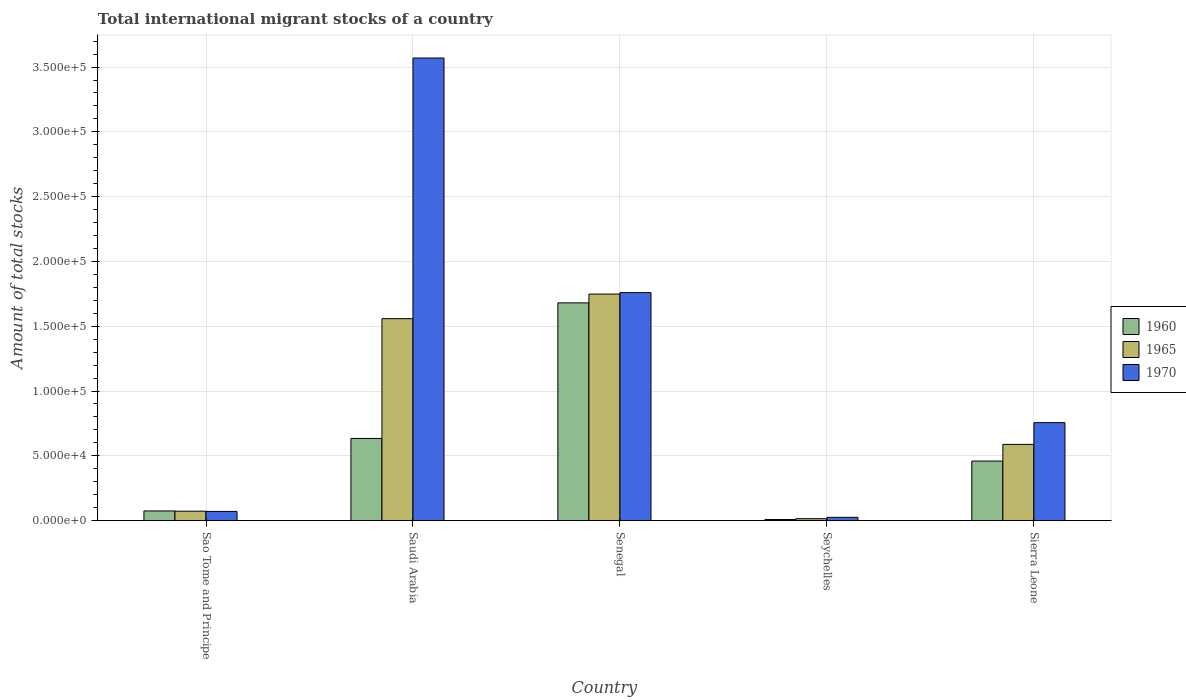Are the number of bars on each tick of the X-axis equal?
Offer a terse response. Yes. How many bars are there on the 5th tick from the left?
Provide a succinct answer. 3. What is the label of the 1st group of bars from the left?
Ensure brevity in your answer.  Sao Tome and Principe. What is the amount of total stocks in in 1970 in Saudi Arabia?
Make the answer very short. 3.57e+05. Across all countries, what is the maximum amount of total stocks in in 1965?
Give a very brief answer. 1.75e+05. Across all countries, what is the minimum amount of total stocks in in 1965?
Keep it short and to the point. 1455. In which country was the amount of total stocks in in 1965 maximum?
Offer a very short reply. Senegal. In which country was the amount of total stocks in in 1960 minimum?
Ensure brevity in your answer.  Seychelles. What is the total amount of total stocks in in 1965 in the graph?
Provide a short and direct response. 3.98e+05. What is the difference between the amount of total stocks in in 1965 in Saudi Arabia and that in Sierra Leone?
Your answer should be compact. 9.70e+04. What is the difference between the amount of total stocks in in 1965 in Sao Tome and Principe and the amount of total stocks in in 1960 in Sierra Leone?
Give a very brief answer. -3.87e+04. What is the average amount of total stocks in in 1960 per country?
Your answer should be compact. 5.71e+04. What is the difference between the amount of total stocks in of/in 1965 and amount of total stocks in of/in 1960 in Sierra Leone?
Provide a short and direct response. 1.29e+04. In how many countries, is the amount of total stocks in in 1960 greater than 190000?
Ensure brevity in your answer.  0. What is the ratio of the amount of total stocks in in 1965 in Sao Tome and Principe to that in Saudi Arabia?
Offer a very short reply. 0.05. Is the difference between the amount of total stocks in in 1965 in Saudi Arabia and Seychelles greater than the difference between the amount of total stocks in in 1960 in Saudi Arabia and Seychelles?
Provide a short and direct response. Yes. What is the difference between the highest and the second highest amount of total stocks in in 1970?
Make the answer very short. 1.81e+05. What is the difference between the highest and the lowest amount of total stocks in in 1960?
Offer a terse response. 1.67e+05. Is the sum of the amount of total stocks in in 1970 in Sao Tome and Principe and Sierra Leone greater than the maximum amount of total stocks in in 1965 across all countries?
Provide a short and direct response. No. Is it the case that in every country, the sum of the amount of total stocks in in 1960 and amount of total stocks in in 1965 is greater than the amount of total stocks in in 1970?
Your answer should be very brief. No. Are all the bars in the graph horizontal?
Offer a very short reply. No. What is the difference between two consecutive major ticks on the Y-axis?
Give a very brief answer. 5.00e+04. Are the values on the major ticks of Y-axis written in scientific E-notation?
Your answer should be very brief. Yes. Does the graph contain grids?
Make the answer very short. Yes. How many legend labels are there?
Offer a terse response. 3. What is the title of the graph?
Make the answer very short. Total international migrant stocks of a country. What is the label or title of the Y-axis?
Provide a short and direct response. Amount of total stocks. What is the Amount of total stocks in 1960 in Sao Tome and Principe?
Your answer should be very brief. 7436. What is the Amount of total stocks of 1965 in Sao Tome and Principe?
Your answer should be very brief. 7253. What is the Amount of total stocks of 1970 in Sao Tome and Principe?
Your answer should be very brief. 7074. What is the Amount of total stocks of 1960 in Saudi Arabia?
Ensure brevity in your answer.  6.34e+04. What is the Amount of total stocks in 1965 in Saudi Arabia?
Make the answer very short. 1.56e+05. What is the Amount of total stocks in 1970 in Saudi Arabia?
Your response must be concise. 3.57e+05. What is the Amount of total stocks in 1960 in Senegal?
Offer a very short reply. 1.68e+05. What is the Amount of total stocks in 1965 in Senegal?
Your response must be concise. 1.75e+05. What is the Amount of total stocks of 1970 in Senegal?
Offer a very short reply. 1.76e+05. What is the Amount of total stocks in 1960 in Seychelles?
Offer a terse response. 845. What is the Amount of total stocks of 1965 in Seychelles?
Offer a terse response. 1455. What is the Amount of total stocks of 1970 in Seychelles?
Keep it short and to the point. 2506. What is the Amount of total stocks in 1960 in Sierra Leone?
Ensure brevity in your answer.  4.59e+04. What is the Amount of total stocks in 1965 in Sierra Leone?
Provide a succinct answer. 5.88e+04. What is the Amount of total stocks of 1970 in Sierra Leone?
Your answer should be very brief. 7.56e+04. Across all countries, what is the maximum Amount of total stocks in 1960?
Offer a terse response. 1.68e+05. Across all countries, what is the maximum Amount of total stocks of 1965?
Provide a short and direct response. 1.75e+05. Across all countries, what is the maximum Amount of total stocks of 1970?
Your answer should be very brief. 3.57e+05. Across all countries, what is the minimum Amount of total stocks in 1960?
Provide a succinct answer. 845. Across all countries, what is the minimum Amount of total stocks in 1965?
Keep it short and to the point. 1455. Across all countries, what is the minimum Amount of total stocks in 1970?
Ensure brevity in your answer.  2506. What is the total Amount of total stocks in 1960 in the graph?
Your response must be concise. 2.86e+05. What is the total Amount of total stocks of 1965 in the graph?
Offer a terse response. 3.98e+05. What is the total Amount of total stocks of 1970 in the graph?
Your answer should be very brief. 6.18e+05. What is the difference between the Amount of total stocks in 1960 in Sao Tome and Principe and that in Saudi Arabia?
Provide a succinct answer. -5.60e+04. What is the difference between the Amount of total stocks in 1965 in Sao Tome and Principe and that in Saudi Arabia?
Your response must be concise. -1.49e+05. What is the difference between the Amount of total stocks in 1970 in Sao Tome and Principe and that in Saudi Arabia?
Offer a very short reply. -3.50e+05. What is the difference between the Amount of total stocks of 1960 in Sao Tome and Principe and that in Senegal?
Provide a succinct answer. -1.61e+05. What is the difference between the Amount of total stocks of 1965 in Sao Tome and Principe and that in Senegal?
Your answer should be compact. -1.68e+05. What is the difference between the Amount of total stocks of 1970 in Sao Tome and Principe and that in Senegal?
Your answer should be very brief. -1.69e+05. What is the difference between the Amount of total stocks of 1960 in Sao Tome and Principe and that in Seychelles?
Give a very brief answer. 6591. What is the difference between the Amount of total stocks of 1965 in Sao Tome and Principe and that in Seychelles?
Provide a short and direct response. 5798. What is the difference between the Amount of total stocks of 1970 in Sao Tome and Principe and that in Seychelles?
Your response must be concise. 4568. What is the difference between the Amount of total stocks in 1960 in Sao Tome and Principe and that in Sierra Leone?
Provide a short and direct response. -3.85e+04. What is the difference between the Amount of total stocks in 1965 in Sao Tome and Principe and that in Sierra Leone?
Keep it short and to the point. -5.16e+04. What is the difference between the Amount of total stocks of 1970 in Sao Tome and Principe and that in Sierra Leone?
Provide a short and direct response. -6.85e+04. What is the difference between the Amount of total stocks in 1960 in Saudi Arabia and that in Senegal?
Offer a very short reply. -1.05e+05. What is the difference between the Amount of total stocks in 1965 in Saudi Arabia and that in Senegal?
Give a very brief answer. -1.90e+04. What is the difference between the Amount of total stocks of 1970 in Saudi Arabia and that in Senegal?
Ensure brevity in your answer.  1.81e+05. What is the difference between the Amount of total stocks of 1960 in Saudi Arabia and that in Seychelles?
Offer a terse response. 6.25e+04. What is the difference between the Amount of total stocks in 1965 in Saudi Arabia and that in Seychelles?
Your response must be concise. 1.54e+05. What is the difference between the Amount of total stocks in 1970 in Saudi Arabia and that in Seychelles?
Your response must be concise. 3.54e+05. What is the difference between the Amount of total stocks of 1960 in Saudi Arabia and that in Sierra Leone?
Provide a short and direct response. 1.75e+04. What is the difference between the Amount of total stocks of 1965 in Saudi Arabia and that in Sierra Leone?
Your answer should be compact. 9.70e+04. What is the difference between the Amount of total stocks of 1970 in Saudi Arabia and that in Sierra Leone?
Keep it short and to the point. 2.81e+05. What is the difference between the Amount of total stocks in 1960 in Senegal and that in Seychelles?
Give a very brief answer. 1.67e+05. What is the difference between the Amount of total stocks of 1965 in Senegal and that in Seychelles?
Your answer should be very brief. 1.73e+05. What is the difference between the Amount of total stocks of 1970 in Senegal and that in Seychelles?
Offer a terse response. 1.73e+05. What is the difference between the Amount of total stocks of 1960 in Senegal and that in Sierra Leone?
Keep it short and to the point. 1.22e+05. What is the difference between the Amount of total stocks of 1965 in Senegal and that in Sierra Leone?
Your answer should be very brief. 1.16e+05. What is the difference between the Amount of total stocks in 1970 in Senegal and that in Sierra Leone?
Offer a terse response. 1.00e+05. What is the difference between the Amount of total stocks in 1960 in Seychelles and that in Sierra Leone?
Offer a terse response. -4.51e+04. What is the difference between the Amount of total stocks in 1965 in Seychelles and that in Sierra Leone?
Your answer should be very brief. -5.74e+04. What is the difference between the Amount of total stocks in 1970 in Seychelles and that in Sierra Leone?
Offer a terse response. -7.31e+04. What is the difference between the Amount of total stocks in 1960 in Sao Tome and Principe and the Amount of total stocks in 1965 in Saudi Arabia?
Your answer should be compact. -1.48e+05. What is the difference between the Amount of total stocks of 1960 in Sao Tome and Principe and the Amount of total stocks of 1970 in Saudi Arabia?
Ensure brevity in your answer.  -3.50e+05. What is the difference between the Amount of total stocks of 1965 in Sao Tome and Principe and the Amount of total stocks of 1970 in Saudi Arabia?
Offer a terse response. -3.50e+05. What is the difference between the Amount of total stocks of 1960 in Sao Tome and Principe and the Amount of total stocks of 1965 in Senegal?
Make the answer very short. -1.67e+05. What is the difference between the Amount of total stocks in 1960 in Sao Tome and Principe and the Amount of total stocks in 1970 in Senegal?
Make the answer very short. -1.68e+05. What is the difference between the Amount of total stocks of 1965 in Sao Tome and Principe and the Amount of total stocks of 1970 in Senegal?
Your answer should be very brief. -1.69e+05. What is the difference between the Amount of total stocks of 1960 in Sao Tome and Principe and the Amount of total stocks of 1965 in Seychelles?
Give a very brief answer. 5981. What is the difference between the Amount of total stocks of 1960 in Sao Tome and Principe and the Amount of total stocks of 1970 in Seychelles?
Your answer should be very brief. 4930. What is the difference between the Amount of total stocks in 1965 in Sao Tome and Principe and the Amount of total stocks in 1970 in Seychelles?
Give a very brief answer. 4747. What is the difference between the Amount of total stocks of 1960 in Sao Tome and Principe and the Amount of total stocks of 1965 in Sierra Leone?
Your answer should be compact. -5.14e+04. What is the difference between the Amount of total stocks of 1960 in Sao Tome and Principe and the Amount of total stocks of 1970 in Sierra Leone?
Your answer should be compact. -6.81e+04. What is the difference between the Amount of total stocks of 1965 in Sao Tome and Principe and the Amount of total stocks of 1970 in Sierra Leone?
Ensure brevity in your answer.  -6.83e+04. What is the difference between the Amount of total stocks of 1960 in Saudi Arabia and the Amount of total stocks of 1965 in Senegal?
Your answer should be compact. -1.11e+05. What is the difference between the Amount of total stocks in 1960 in Saudi Arabia and the Amount of total stocks in 1970 in Senegal?
Provide a succinct answer. -1.13e+05. What is the difference between the Amount of total stocks in 1965 in Saudi Arabia and the Amount of total stocks in 1970 in Senegal?
Make the answer very short. -2.01e+04. What is the difference between the Amount of total stocks of 1960 in Saudi Arabia and the Amount of total stocks of 1965 in Seychelles?
Ensure brevity in your answer.  6.19e+04. What is the difference between the Amount of total stocks of 1960 in Saudi Arabia and the Amount of total stocks of 1970 in Seychelles?
Your response must be concise. 6.09e+04. What is the difference between the Amount of total stocks of 1965 in Saudi Arabia and the Amount of total stocks of 1970 in Seychelles?
Your response must be concise. 1.53e+05. What is the difference between the Amount of total stocks in 1960 in Saudi Arabia and the Amount of total stocks in 1965 in Sierra Leone?
Offer a very short reply. 4580. What is the difference between the Amount of total stocks of 1960 in Saudi Arabia and the Amount of total stocks of 1970 in Sierra Leone?
Offer a very short reply. -1.22e+04. What is the difference between the Amount of total stocks of 1965 in Saudi Arabia and the Amount of total stocks of 1970 in Sierra Leone?
Your answer should be compact. 8.02e+04. What is the difference between the Amount of total stocks of 1960 in Senegal and the Amount of total stocks of 1965 in Seychelles?
Make the answer very short. 1.67e+05. What is the difference between the Amount of total stocks in 1960 in Senegal and the Amount of total stocks in 1970 in Seychelles?
Keep it short and to the point. 1.66e+05. What is the difference between the Amount of total stocks in 1965 in Senegal and the Amount of total stocks in 1970 in Seychelles?
Offer a terse response. 1.72e+05. What is the difference between the Amount of total stocks of 1960 in Senegal and the Amount of total stocks of 1965 in Sierra Leone?
Provide a succinct answer. 1.09e+05. What is the difference between the Amount of total stocks in 1960 in Senegal and the Amount of total stocks in 1970 in Sierra Leone?
Ensure brevity in your answer.  9.24e+04. What is the difference between the Amount of total stocks of 1965 in Senegal and the Amount of total stocks of 1970 in Sierra Leone?
Your answer should be very brief. 9.92e+04. What is the difference between the Amount of total stocks in 1960 in Seychelles and the Amount of total stocks in 1965 in Sierra Leone?
Your response must be concise. -5.80e+04. What is the difference between the Amount of total stocks of 1960 in Seychelles and the Amount of total stocks of 1970 in Sierra Leone?
Make the answer very short. -7.47e+04. What is the difference between the Amount of total stocks of 1965 in Seychelles and the Amount of total stocks of 1970 in Sierra Leone?
Keep it short and to the point. -7.41e+04. What is the average Amount of total stocks of 1960 per country?
Your answer should be compact. 5.71e+04. What is the average Amount of total stocks in 1965 per country?
Offer a terse response. 7.96e+04. What is the average Amount of total stocks in 1970 per country?
Your response must be concise. 1.24e+05. What is the difference between the Amount of total stocks in 1960 and Amount of total stocks in 1965 in Sao Tome and Principe?
Your answer should be compact. 183. What is the difference between the Amount of total stocks in 1960 and Amount of total stocks in 1970 in Sao Tome and Principe?
Offer a terse response. 362. What is the difference between the Amount of total stocks in 1965 and Amount of total stocks in 1970 in Sao Tome and Principe?
Your answer should be compact. 179. What is the difference between the Amount of total stocks in 1960 and Amount of total stocks in 1965 in Saudi Arabia?
Provide a short and direct response. -9.24e+04. What is the difference between the Amount of total stocks in 1960 and Amount of total stocks in 1970 in Saudi Arabia?
Offer a very short reply. -2.94e+05. What is the difference between the Amount of total stocks of 1965 and Amount of total stocks of 1970 in Saudi Arabia?
Provide a short and direct response. -2.01e+05. What is the difference between the Amount of total stocks in 1960 and Amount of total stocks in 1965 in Senegal?
Keep it short and to the point. -6804. What is the difference between the Amount of total stocks of 1960 and Amount of total stocks of 1970 in Senegal?
Give a very brief answer. -7897. What is the difference between the Amount of total stocks in 1965 and Amount of total stocks in 1970 in Senegal?
Your answer should be compact. -1093. What is the difference between the Amount of total stocks of 1960 and Amount of total stocks of 1965 in Seychelles?
Provide a short and direct response. -610. What is the difference between the Amount of total stocks of 1960 and Amount of total stocks of 1970 in Seychelles?
Provide a short and direct response. -1661. What is the difference between the Amount of total stocks of 1965 and Amount of total stocks of 1970 in Seychelles?
Offer a very short reply. -1051. What is the difference between the Amount of total stocks in 1960 and Amount of total stocks in 1965 in Sierra Leone?
Offer a terse response. -1.29e+04. What is the difference between the Amount of total stocks in 1960 and Amount of total stocks in 1970 in Sierra Leone?
Give a very brief answer. -2.97e+04. What is the difference between the Amount of total stocks in 1965 and Amount of total stocks in 1970 in Sierra Leone?
Provide a short and direct response. -1.68e+04. What is the ratio of the Amount of total stocks of 1960 in Sao Tome and Principe to that in Saudi Arabia?
Ensure brevity in your answer.  0.12. What is the ratio of the Amount of total stocks in 1965 in Sao Tome and Principe to that in Saudi Arabia?
Your answer should be compact. 0.05. What is the ratio of the Amount of total stocks in 1970 in Sao Tome and Principe to that in Saudi Arabia?
Offer a terse response. 0.02. What is the ratio of the Amount of total stocks of 1960 in Sao Tome and Principe to that in Senegal?
Make the answer very short. 0.04. What is the ratio of the Amount of total stocks in 1965 in Sao Tome and Principe to that in Senegal?
Offer a very short reply. 0.04. What is the ratio of the Amount of total stocks in 1970 in Sao Tome and Principe to that in Senegal?
Ensure brevity in your answer.  0.04. What is the ratio of the Amount of total stocks in 1960 in Sao Tome and Principe to that in Seychelles?
Your response must be concise. 8.8. What is the ratio of the Amount of total stocks of 1965 in Sao Tome and Principe to that in Seychelles?
Keep it short and to the point. 4.98. What is the ratio of the Amount of total stocks in 1970 in Sao Tome and Principe to that in Seychelles?
Your response must be concise. 2.82. What is the ratio of the Amount of total stocks in 1960 in Sao Tome and Principe to that in Sierra Leone?
Your answer should be very brief. 0.16. What is the ratio of the Amount of total stocks in 1965 in Sao Tome and Principe to that in Sierra Leone?
Keep it short and to the point. 0.12. What is the ratio of the Amount of total stocks of 1970 in Sao Tome and Principe to that in Sierra Leone?
Ensure brevity in your answer.  0.09. What is the ratio of the Amount of total stocks in 1960 in Saudi Arabia to that in Senegal?
Offer a very short reply. 0.38. What is the ratio of the Amount of total stocks in 1965 in Saudi Arabia to that in Senegal?
Make the answer very short. 0.89. What is the ratio of the Amount of total stocks in 1970 in Saudi Arabia to that in Senegal?
Offer a terse response. 2.03. What is the ratio of the Amount of total stocks of 1960 in Saudi Arabia to that in Seychelles?
Give a very brief answer. 75.02. What is the ratio of the Amount of total stocks of 1965 in Saudi Arabia to that in Seychelles?
Your response must be concise. 107.09. What is the ratio of the Amount of total stocks in 1970 in Saudi Arabia to that in Seychelles?
Provide a succinct answer. 142.46. What is the ratio of the Amount of total stocks in 1960 in Saudi Arabia to that in Sierra Leone?
Your answer should be very brief. 1.38. What is the ratio of the Amount of total stocks of 1965 in Saudi Arabia to that in Sierra Leone?
Offer a very short reply. 2.65. What is the ratio of the Amount of total stocks in 1970 in Saudi Arabia to that in Sierra Leone?
Make the answer very short. 4.72. What is the ratio of the Amount of total stocks in 1960 in Senegal to that in Seychelles?
Provide a short and direct response. 198.84. What is the ratio of the Amount of total stocks of 1965 in Senegal to that in Seychelles?
Offer a terse response. 120.15. What is the ratio of the Amount of total stocks in 1970 in Senegal to that in Seychelles?
Offer a terse response. 70.2. What is the ratio of the Amount of total stocks in 1960 in Senegal to that in Sierra Leone?
Give a very brief answer. 3.66. What is the ratio of the Amount of total stocks in 1965 in Senegal to that in Sierra Leone?
Your response must be concise. 2.97. What is the ratio of the Amount of total stocks in 1970 in Senegal to that in Sierra Leone?
Your response must be concise. 2.33. What is the ratio of the Amount of total stocks in 1960 in Seychelles to that in Sierra Leone?
Provide a succinct answer. 0.02. What is the ratio of the Amount of total stocks of 1965 in Seychelles to that in Sierra Leone?
Make the answer very short. 0.02. What is the ratio of the Amount of total stocks of 1970 in Seychelles to that in Sierra Leone?
Your answer should be compact. 0.03. What is the difference between the highest and the second highest Amount of total stocks of 1960?
Keep it short and to the point. 1.05e+05. What is the difference between the highest and the second highest Amount of total stocks of 1965?
Offer a terse response. 1.90e+04. What is the difference between the highest and the second highest Amount of total stocks in 1970?
Make the answer very short. 1.81e+05. What is the difference between the highest and the lowest Amount of total stocks in 1960?
Ensure brevity in your answer.  1.67e+05. What is the difference between the highest and the lowest Amount of total stocks of 1965?
Give a very brief answer. 1.73e+05. What is the difference between the highest and the lowest Amount of total stocks of 1970?
Make the answer very short. 3.54e+05. 